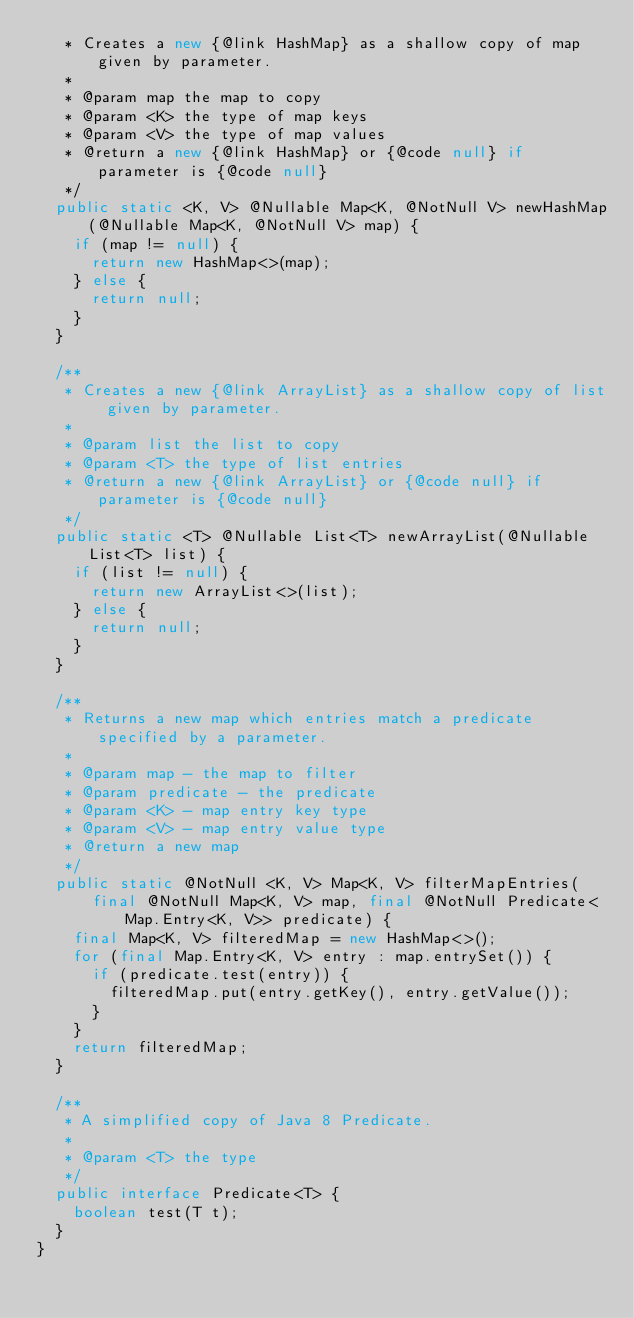<code> <loc_0><loc_0><loc_500><loc_500><_Java_>   * Creates a new {@link HashMap} as a shallow copy of map given by parameter.
   *
   * @param map the map to copy
   * @param <K> the type of map keys
   * @param <V> the type of map values
   * @return a new {@link HashMap} or {@code null} if parameter is {@code null}
   */
  public static <K, V> @Nullable Map<K, @NotNull V> newHashMap(@Nullable Map<K, @NotNull V> map) {
    if (map != null) {
      return new HashMap<>(map);
    } else {
      return null;
    }
  }

  /**
   * Creates a new {@link ArrayList} as a shallow copy of list given by parameter.
   *
   * @param list the list to copy
   * @param <T> the type of list entries
   * @return a new {@link ArrayList} or {@code null} if parameter is {@code null}
   */
  public static <T> @Nullable List<T> newArrayList(@Nullable List<T> list) {
    if (list != null) {
      return new ArrayList<>(list);
    } else {
      return null;
    }
  }

  /**
   * Returns a new map which entries match a predicate specified by a parameter.
   *
   * @param map - the map to filter
   * @param predicate - the predicate
   * @param <K> - map entry key type
   * @param <V> - map entry value type
   * @return a new map
   */
  public static @NotNull <K, V> Map<K, V> filterMapEntries(
      final @NotNull Map<K, V> map, final @NotNull Predicate<Map.Entry<K, V>> predicate) {
    final Map<K, V> filteredMap = new HashMap<>();
    for (final Map.Entry<K, V> entry : map.entrySet()) {
      if (predicate.test(entry)) {
        filteredMap.put(entry.getKey(), entry.getValue());
      }
    }
    return filteredMap;
  }

  /**
   * A simplified copy of Java 8 Predicate.
   *
   * @param <T> the type
   */
  public interface Predicate<T> {
    boolean test(T t);
  }
}
</code> 